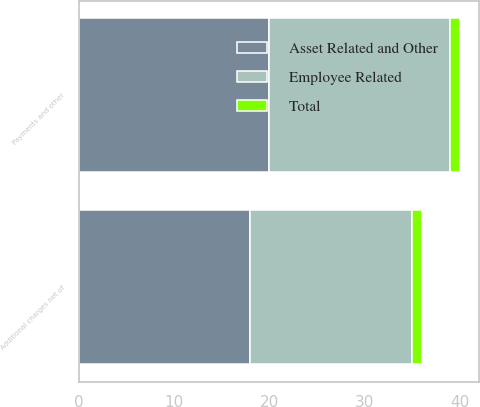<chart> <loc_0><loc_0><loc_500><loc_500><stacked_bar_chart><ecel><fcel>Additional charges net of<fcel>Payments and other<nl><fcel>Employee Related<fcel>17<fcel>19<nl><fcel>Total<fcel>1<fcel>1<nl><fcel>Asset Related and Other<fcel>18<fcel>20<nl></chart> 